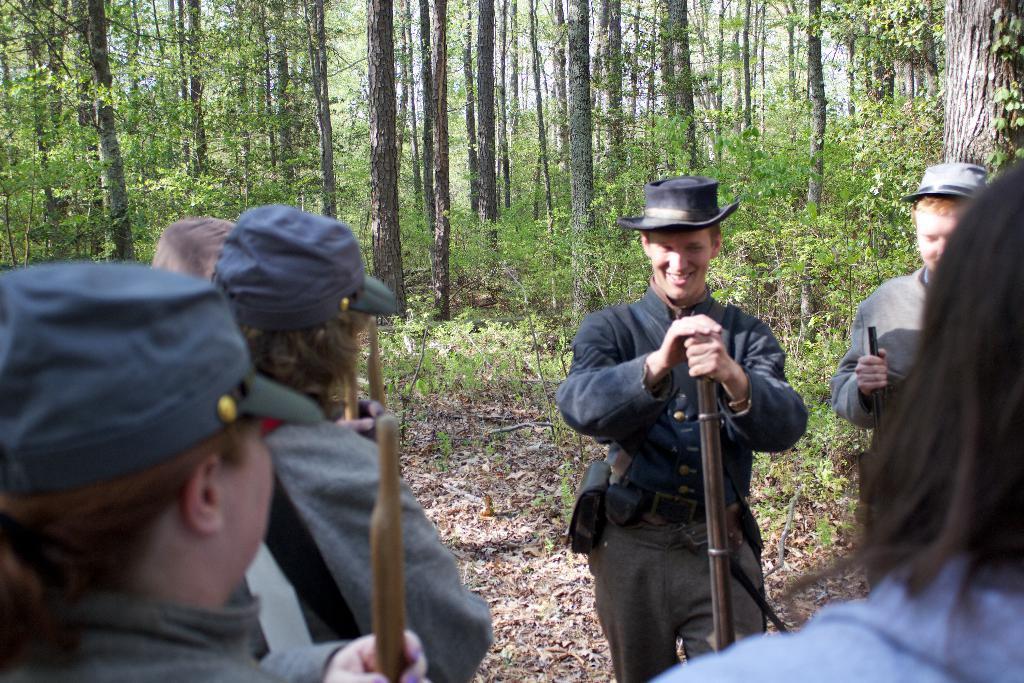Can you describe this image briefly? In this image we can see a man is standing, and smiling, and holding some object in the hands, in front here are the group of people standing, here are the trees, here are the dried twigs. 